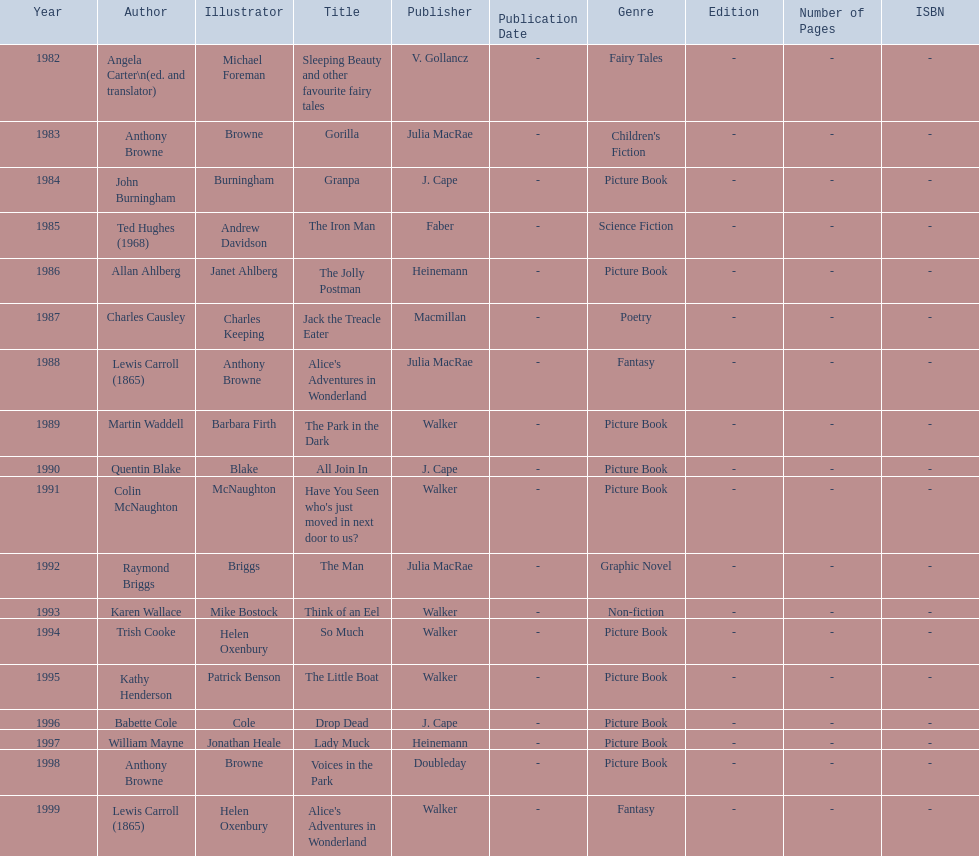Which book won the award a total of 2 times? Alice's Adventures in Wonderland. 